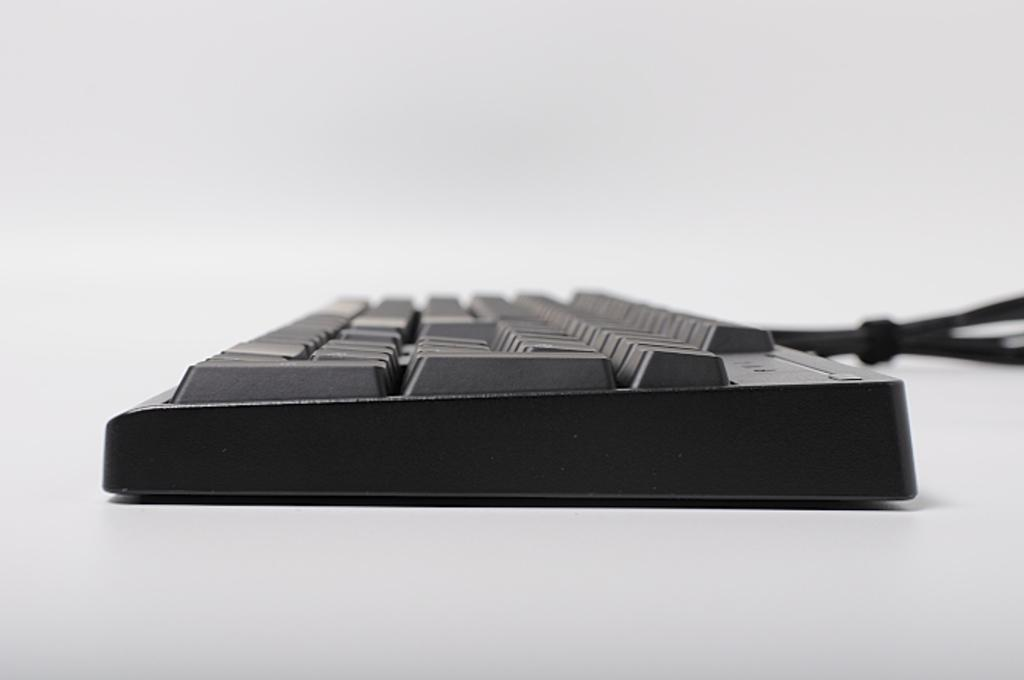What is the main object in the image? There is a keyboard in the image. What is the keyboard placed on? The keyboard is on a white surface. Can you describe the background of the image? The background of the image is blurred. How many cows are visible in the image? There are no cows present in the image; it features a keyboard on a white surface with a blurred background. 